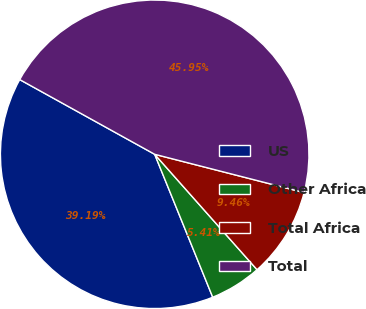<chart> <loc_0><loc_0><loc_500><loc_500><pie_chart><fcel>US<fcel>Other Africa<fcel>Total Africa<fcel>Total<nl><fcel>39.19%<fcel>5.41%<fcel>9.46%<fcel>45.95%<nl></chart> 